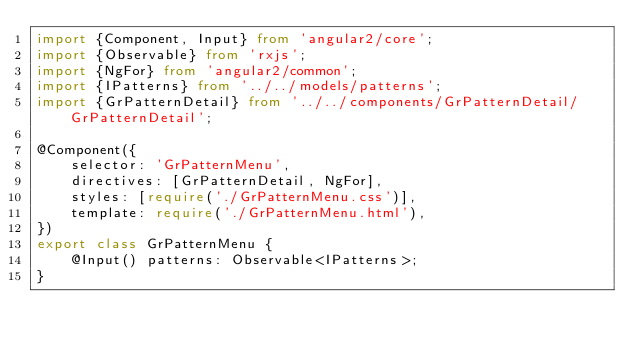Convert code to text. <code><loc_0><loc_0><loc_500><loc_500><_TypeScript_>import {Component, Input} from 'angular2/core';
import {Observable} from 'rxjs';
import {NgFor} from 'angular2/common';
import {IPatterns} from '../../models/patterns';
import {GrPatternDetail} from '../../components/GrPatternDetail/GrPatternDetail';

@Component({
    selector: 'GrPatternMenu',
    directives: [GrPatternDetail, NgFor],
    styles: [require('./GrPatternMenu.css')],
    template: require('./GrPatternMenu.html'),
})
export class GrPatternMenu {
    @Input() patterns: Observable<IPatterns>;
}
</code> 